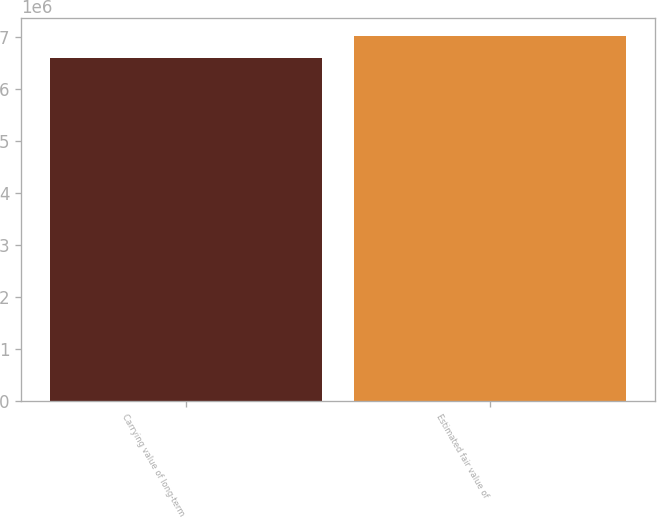Convert chart. <chart><loc_0><loc_0><loc_500><loc_500><bar_chart><fcel>Carrying value of long-term<fcel>Estimated fair value of<nl><fcel>6.59638e+06<fcel>7.01264e+06<nl></chart> 